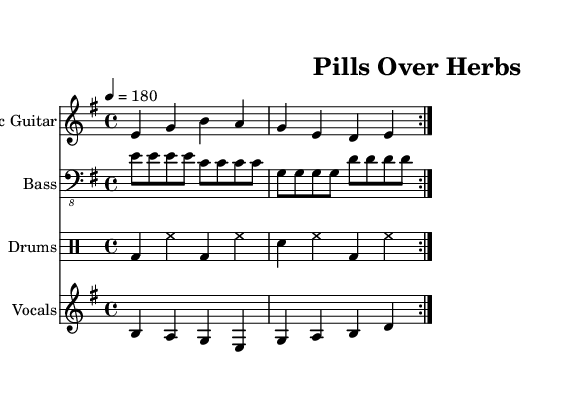What is the key signature of this music? The key signature is indicated by the sharp or flat symbols at the start of the staff. In this case, the sheet music does not have any sharps or flats, which indicates that it is in E minor.
Answer: E minor What is the time signature of this music? The time signature is shown as a fraction at the beginning of the staff. In this sheet music, the time signature is 4/4, indicating four beats per measure.
Answer: 4/4 What is the tempo marking for this piece? The tempo marking is indicated in the sheet music as a number associated with the quarter note. Here, it says "4 = 180," which means there are 180 beats per minute.
Answer: 180 How many times is the main theme repeated in the music? The repeated sections are indicated by the "volta" command in the music. In this case, the music shows that the primary themes are repeated 2 times.
Answer: 2 What do the lyrics of the verse express? Analyzing the provided lyrics, the verse discusses a conflict with parental beliefs regarding remedies, contrasting natural and conventional medicine. This showcases the rebellious theme commonly found in punk music.
Answer: Conflict with parents What is the primary message of the chorus? The chorus lyrics clearly convey a strong preference for pills over herbal remedies, reinforcing a rejection of parental beliefs. The repetition emphasizes the desire for freedom from constraints.
Answer: Pills over herbs What is the type of drum pattern used in the piece? The drum part shows a sequence primarily made up of bass drum and snare drum hits in a driving pattern typical of punk music, contributing to its fast-paced nature.
Answer: Driving pattern 